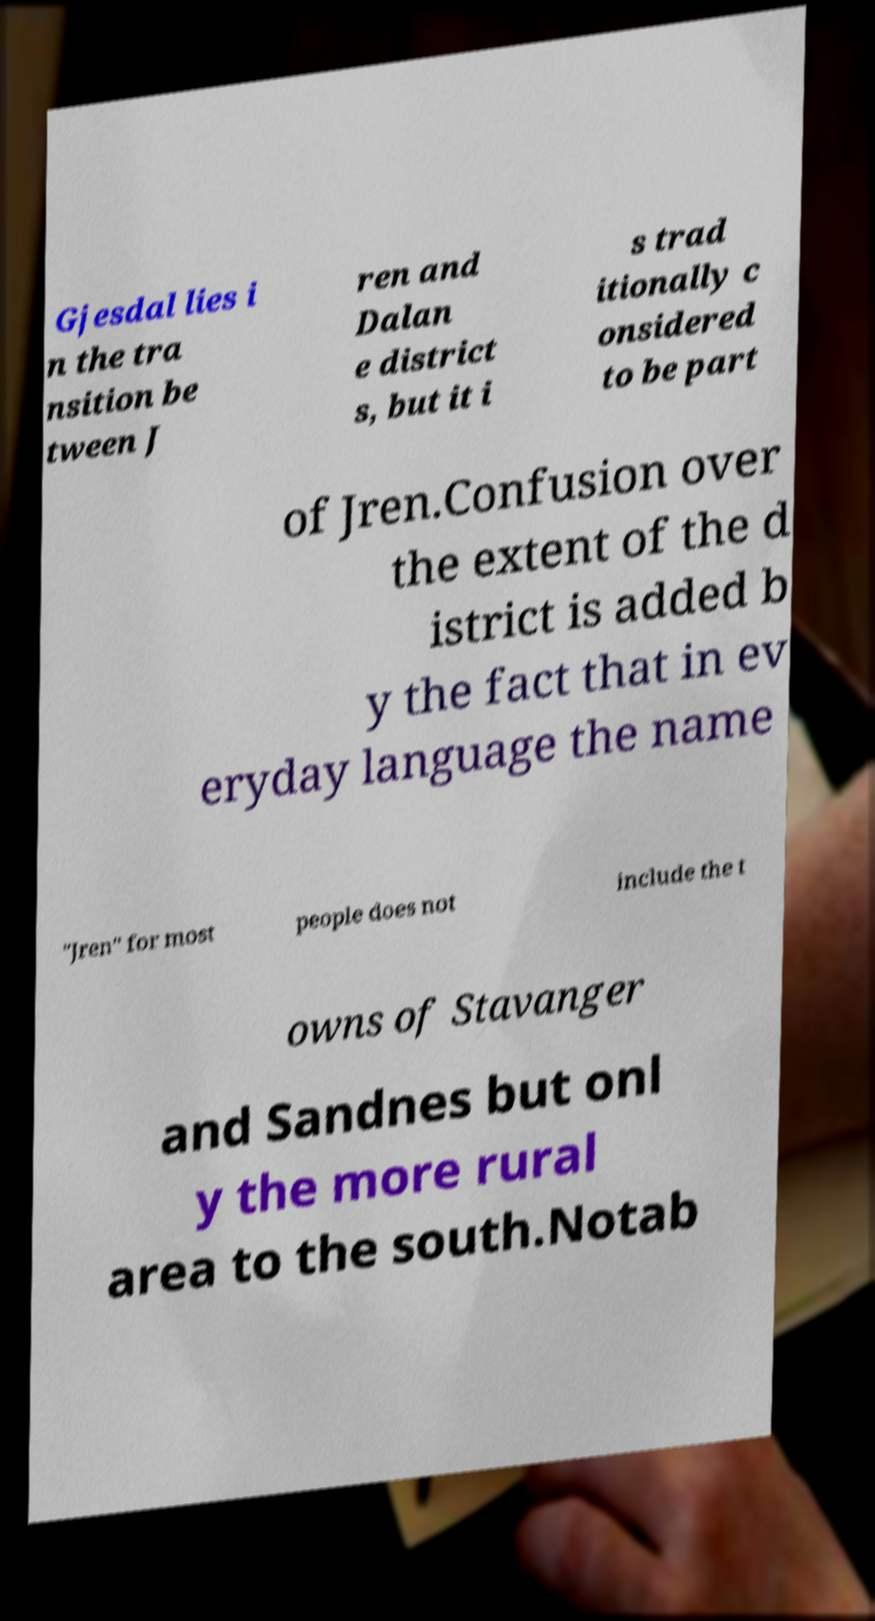There's text embedded in this image that I need extracted. Can you transcribe it verbatim? Gjesdal lies i n the tra nsition be tween J ren and Dalan e district s, but it i s trad itionally c onsidered to be part of Jren.Confusion over the extent of the d istrict is added b y the fact that in ev eryday language the name "Jren" for most people does not include the t owns of Stavanger and Sandnes but onl y the more rural area to the south.Notab 